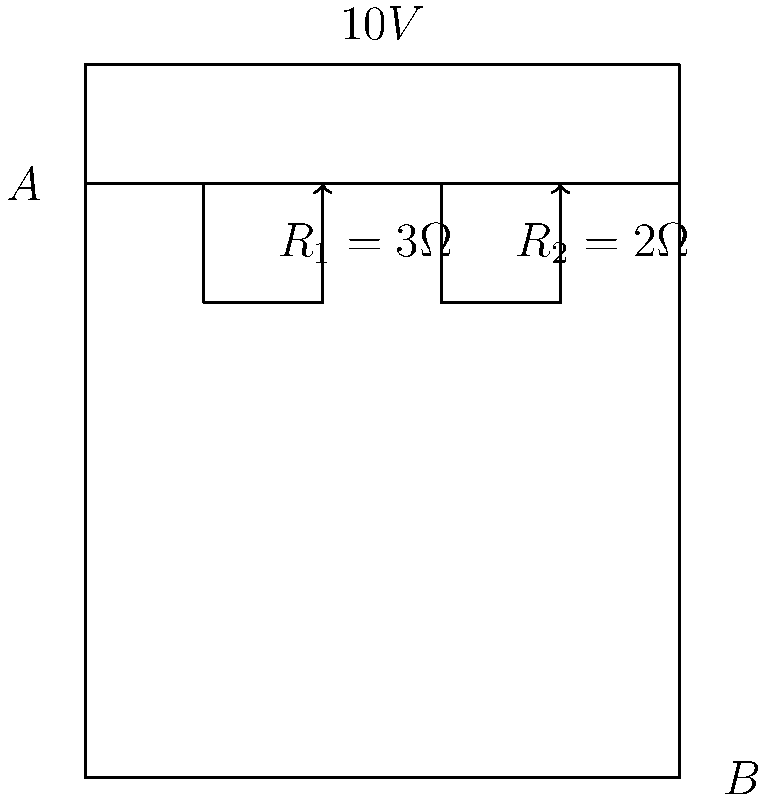In the circuit diagram above, calculate the voltage drop across resistor $R_2$. Assume the current flows from point A to point B. To solve this problem, we'll follow these steps:

1) First, we need to calculate the total resistance of the circuit:
   $R_{total} = R_1 + R_2 = 3\Omega + 2\Omega = 5\Omega$

2) Now we can calculate the current in the circuit using Ohm's Law:
   $I = \frac{V}{R_{total}} = \frac{10V}{5\Omega} = 2A$

3) The voltage drop across $R_2$ can be calculated using Ohm's Law again:
   $V_{R2} = I \times R_2 = 2A \times 2\Omega = 4V$

Therefore, the voltage drop across resistor $R_2$ is 4V.
Answer: $4V$ 